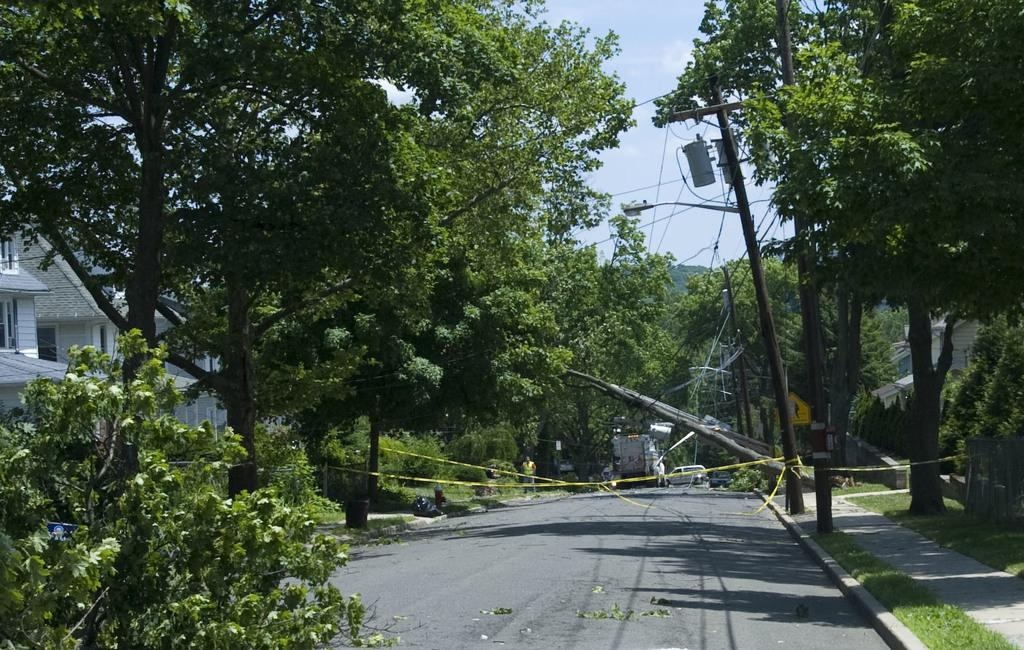What type of vegetation can be seen in the image? There are trees in the image. What structures are present to provide illumination in the image? There are light poles in the image. What type of barrier is visible in the image? There is a fence in the image. What type of ground cover is present in the image? There is grass in the image. What type of transportation is visible on the road in the image? There are vehicles on the road in the image. What type of infrastructure is present in the image? There are wires and buildings in the image. What part of the natural environment is visible in the image? The sky is visible in the background of the image. What time of day was the image likely taken? The image was likely taken during the day, as there is no indication of darkness or artificial lighting. What type of owl can be seen perched on the fence in the image? There is no owl present in the image; it features trees, light poles, a fence, grass, vehicles, wires, buildings, and the sky. What holiday is being celebrated in the image? There is no indication of a holiday being celebrated in the image. 